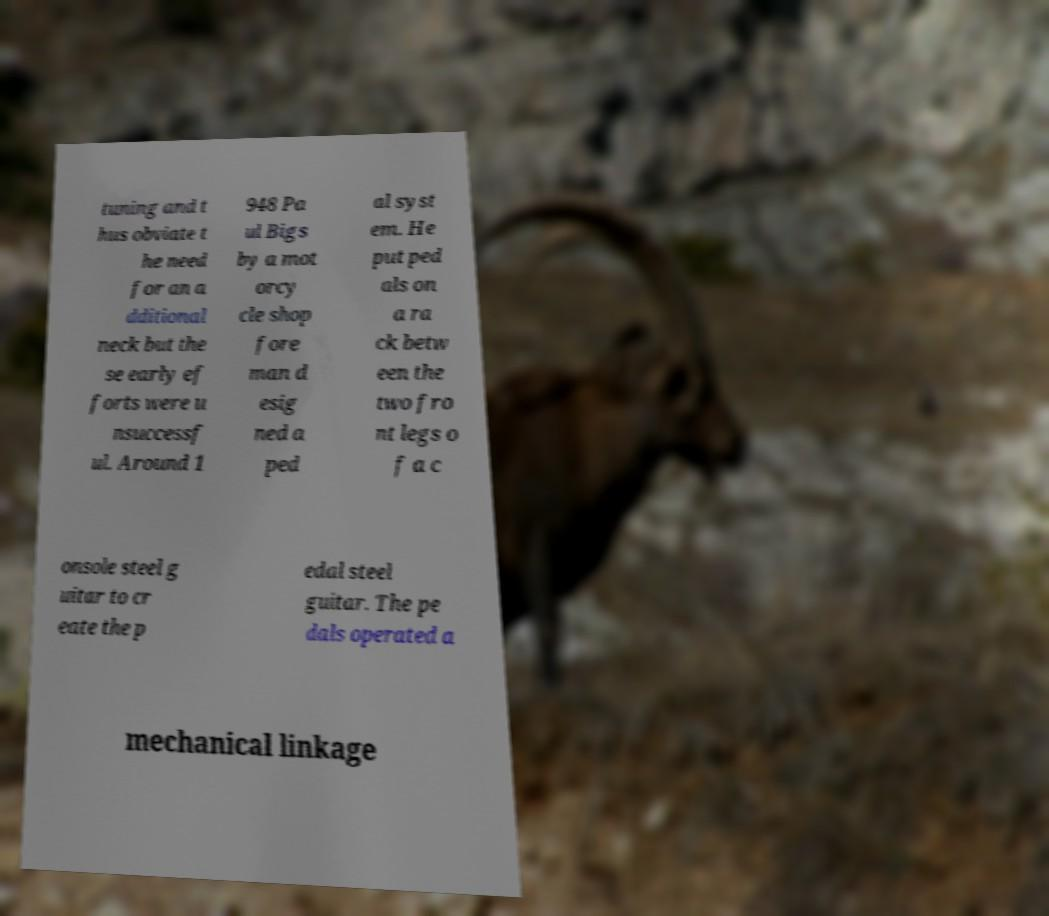Could you assist in decoding the text presented in this image and type it out clearly? tuning and t hus obviate t he need for an a dditional neck but the se early ef forts were u nsuccessf ul. Around 1 948 Pa ul Bigs by a mot orcy cle shop fore man d esig ned a ped al syst em. He put ped als on a ra ck betw een the two fro nt legs o f a c onsole steel g uitar to cr eate the p edal steel guitar. The pe dals operated a mechanical linkage 